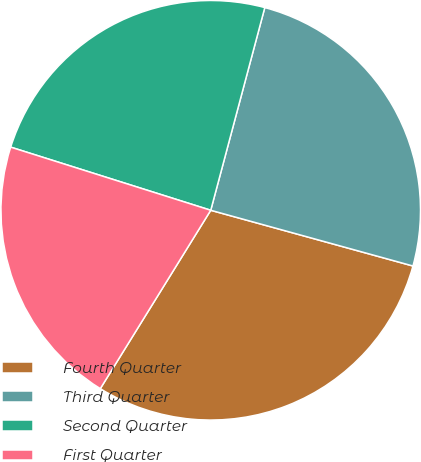Convert chart. <chart><loc_0><loc_0><loc_500><loc_500><pie_chart><fcel>Fourth Quarter<fcel>Third Quarter<fcel>Second Quarter<fcel>First Quarter<nl><fcel>29.54%<fcel>25.13%<fcel>24.28%<fcel>21.04%<nl></chart> 